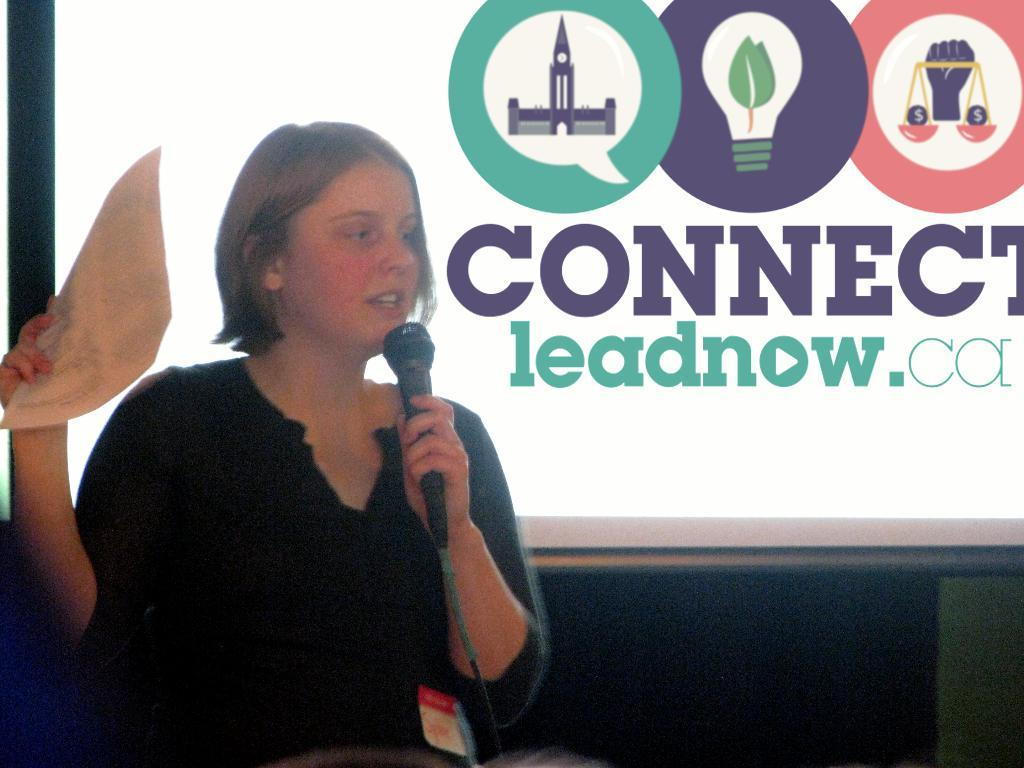Who is the main subject in the image? There is a lady in the image. What is the lady holding in her hands? The lady is holding a microphone and a paper. What is the lady doing in the image? The lady is talking. What can be seen in the background of the image? There is a screen in the background of the image. What is written on the screen? There is writing on the screen. Are there any symbols or logos present in the image? Yes, there are logos present in the image. How many bikes are being used as bait in the image? There are no bikes or bait present in the image. 